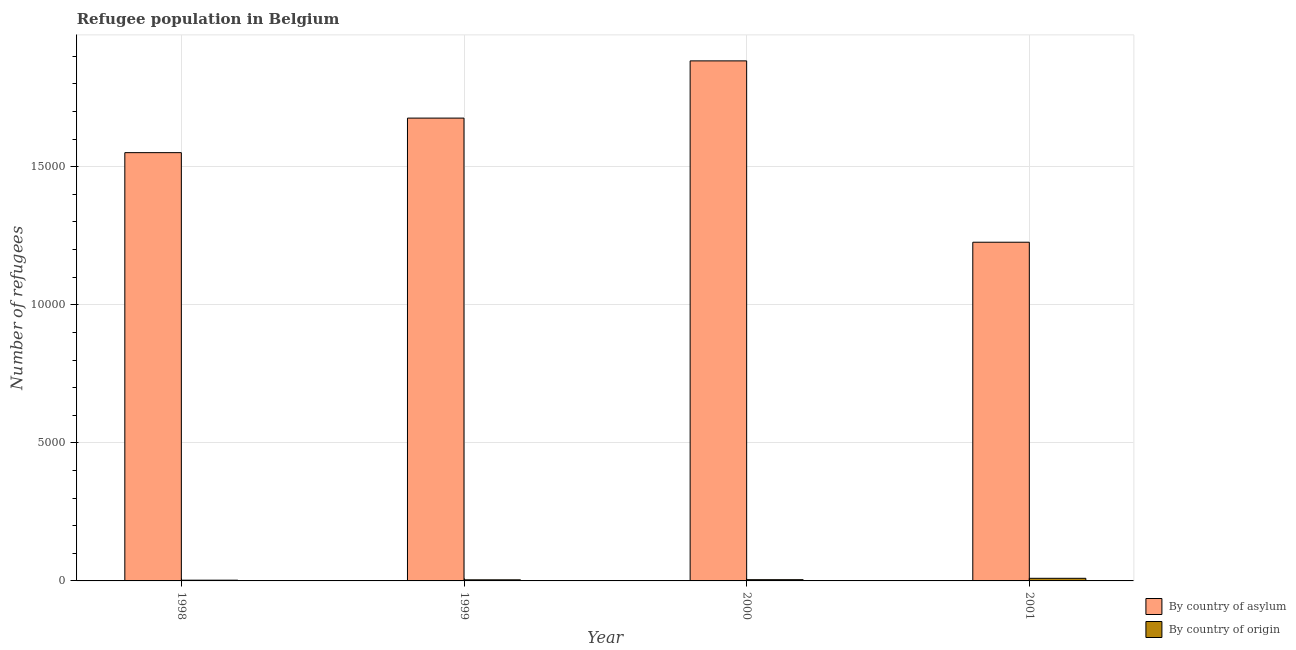How many groups of bars are there?
Your answer should be very brief. 4. Are the number of bars per tick equal to the number of legend labels?
Keep it short and to the point. Yes. Are the number of bars on each tick of the X-axis equal?
Your response must be concise. Yes. What is the number of refugees by country of origin in 2001?
Your answer should be very brief. 95. Across all years, what is the maximum number of refugees by country of origin?
Make the answer very short. 95. Across all years, what is the minimum number of refugees by country of origin?
Your response must be concise. 27. In which year was the number of refugees by country of asylum maximum?
Provide a short and direct response. 2000. What is the total number of refugees by country of origin in the graph?
Make the answer very short. 207. What is the difference between the number of refugees by country of origin in 1998 and that in 2001?
Provide a succinct answer. -68. What is the difference between the number of refugees by country of origin in 1998 and the number of refugees by country of asylum in 2000?
Offer a very short reply. -18. What is the average number of refugees by country of origin per year?
Your response must be concise. 51.75. In the year 2001, what is the difference between the number of refugees by country of origin and number of refugees by country of asylum?
Make the answer very short. 0. What is the ratio of the number of refugees by country of origin in 2000 to that in 2001?
Give a very brief answer. 0.47. What is the difference between the highest and the second highest number of refugees by country of asylum?
Keep it short and to the point. 2072. What is the difference between the highest and the lowest number of refugees by country of origin?
Keep it short and to the point. 68. What does the 1st bar from the left in 2000 represents?
Your answer should be very brief. By country of asylum. What does the 2nd bar from the right in 2000 represents?
Your response must be concise. By country of asylum. How many years are there in the graph?
Offer a terse response. 4. What is the difference between two consecutive major ticks on the Y-axis?
Provide a short and direct response. 5000. Does the graph contain any zero values?
Offer a very short reply. No. Does the graph contain grids?
Make the answer very short. Yes. Where does the legend appear in the graph?
Ensure brevity in your answer.  Bottom right. How many legend labels are there?
Keep it short and to the point. 2. How are the legend labels stacked?
Make the answer very short. Vertical. What is the title of the graph?
Offer a very short reply. Refugee population in Belgium. What is the label or title of the Y-axis?
Keep it short and to the point. Number of refugees. What is the Number of refugees in By country of asylum in 1998?
Give a very brief answer. 1.55e+04. What is the Number of refugees in By country of origin in 1998?
Make the answer very short. 27. What is the Number of refugees in By country of asylum in 1999?
Provide a short and direct response. 1.68e+04. What is the Number of refugees in By country of origin in 1999?
Give a very brief answer. 40. What is the Number of refugees in By country of asylum in 2000?
Make the answer very short. 1.88e+04. What is the Number of refugees in By country of asylum in 2001?
Offer a very short reply. 1.23e+04. What is the Number of refugees in By country of origin in 2001?
Your answer should be very brief. 95. Across all years, what is the maximum Number of refugees in By country of asylum?
Keep it short and to the point. 1.88e+04. Across all years, what is the minimum Number of refugees in By country of asylum?
Your answer should be compact. 1.23e+04. What is the total Number of refugees of By country of asylum in the graph?
Provide a short and direct response. 6.34e+04. What is the total Number of refugees in By country of origin in the graph?
Your answer should be compact. 207. What is the difference between the Number of refugees in By country of asylum in 1998 and that in 1999?
Give a very brief answer. -1251. What is the difference between the Number of refugees of By country of origin in 1998 and that in 1999?
Provide a succinct answer. -13. What is the difference between the Number of refugees of By country of asylum in 1998 and that in 2000?
Your answer should be compact. -3323. What is the difference between the Number of refugees of By country of origin in 1998 and that in 2000?
Offer a terse response. -18. What is the difference between the Number of refugees of By country of asylum in 1998 and that in 2001?
Your answer should be very brief. 3244. What is the difference between the Number of refugees in By country of origin in 1998 and that in 2001?
Ensure brevity in your answer.  -68. What is the difference between the Number of refugees of By country of asylum in 1999 and that in 2000?
Your response must be concise. -2072. What is the difference between the Number of refugees of By country of asylum in 1999 and that in 2001?
Give a very brief answer. 4495. What is the difference between the Number of refugees of By country of origin in 1999 and that in 2001?
Give a very brief answer. -55. What is the difference between the Number of refugees of By country of asylum in 2000 and that in 2001?
Offer a terse response. 6567. What is the difference between the Number of refugees of By country of asylum in 1998 and the Number of refugees of By country of origin in 1999?
Ensure brevity in your answer.  1.55e+04. What is the difference between the Number of refugees in By country of asylum in 1998 and the Number of refugees in By country of origin in 2000?
Make the answer very short. 1.55e+04. What is the difference between the Number of refugees in By country of asylum in 1998 and the Number of refugees in By country of origin in 2001?
Provide a succinct answer. 1.54e+04. What is the difference between the Number of refugees of By country of asylum in 1999 and the Number of refugees of By country of origin in 2000?
Your answer should be very brief. 1.67e+04. What is the difference between the Number of refugees of By country of asylum in 1999 and the Number of refugees of By country of origin in 2001?
Make the answer very short. 1.67e+04. What is the difference between the Number of refugees in By country of asylum in 2000 and the Number of refugees in By country of origin in 2001?
Your answer should be very brief. 1.87e+04. What is the average Number of refugees of By country of asylum per year?
Your response must be concise. 1.58e+04. What is the average Number of refugees of By country of origin per year?
Offer a very short reply. 51.75. In the year 1998, what is the difference between the Number of refugees in By country of asylum and Number of refugees in By country of origin?
Your answer should be compact. 1.55e+04. In the year 1999, what is the difference between the Number of refugees of By country of asylum and Number of refugees of By country of origin?
Give a very brief answer. 1.67e+04. In the year 2000, what is the difference between the Number of refugees of By country of asylum and Number of refugees of By country of origin?
Keep it short and to the point. 1.88e+04. In the year 2001, what is the difference between the Number of refugees of By country of asylum and Number of refugees of By country of origin?
Give a very brief answer. 1.22e+04. What is the ratio of the Number of refugees of By country of asylum in 1998 to that in 1999?
Ensure brevity in your answer.  0.93. What is the ratio of the Number of refugees in By country of origin in 1998 to that in 1999?
Offer a very short reply. 0.68. What is the ratio of the Number of refugees in By country of asylum in 1998 to that in 2000?
Make the answer very short. 0.82. What is the ratio of the Number of refugees of By country of origin in 1998 to that in 2000?
Give a very brief answer. 0.6. What is the ratio of the Number of refugees in By country of asylum in 1998 to that in 2001?
Your response must be concise. 1.26. What is the ratio of the Number of refugees of By country of origin in 1998 to that in 2001?
Give a very brief answer. 0.28. What is the ratio of the Number of refugees of By country of asylum in 1999 to that in 2000?
Provide a short and direct response. 0.89. What is the ratio of the Number of refugees in By country of origin in 1999 to that in 2000?
Offer a very short reply. 0.89. What is the ratio of the Number of refugees in By country of asylum in 1999 to that in 2001?
Offer a terse response. 1.37. What is the ratio of the Number of refugees in By country of origin in 1999 to that in 2001?
Your answer should be very brief. 0.42. What is the ratio of the Number of refugees in By country of asylum in 2000 to that in 2001?
Give a very brief answer. 1.54. What is the ratio of the Number of refugees of By country of origin in 2000 to that in 2001?
Ensure brevity in your answer.  0.47. What is the difference between the highest and the second highest Number of refugees in By country of asylum?
Ensure brevity in your answer.  2072. What is the difference between the highest and the second highest Number of refugees of By country of origin?
Make the answer very short. 50. What is the difference between the highest and the lowest Number of refugees of By country of asylum?
Provide a short and direct response. 6567. What is the difference between the highest and the lowest Number of refugees in By country of origin?
Offer a very short reply. 68. 